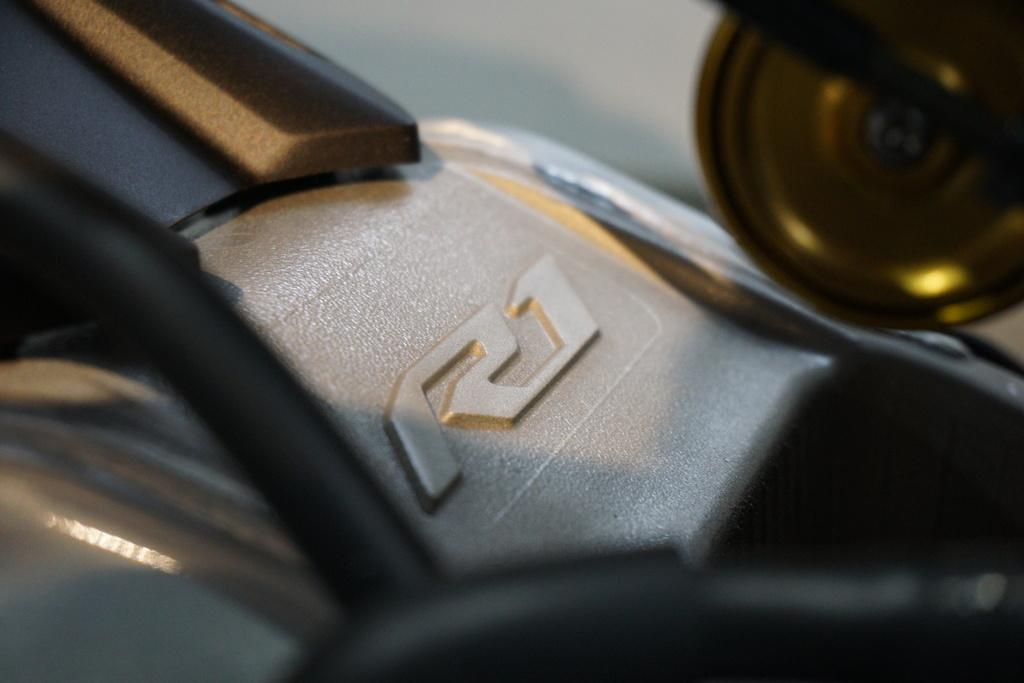What can be observed in the image? There is a zoomed-in image of an object. Can you describe the colors of the object in the image? The object has brown, black, and cream colors. What type of oven is visible in the image? There is no oven present in the image; it is a zoomed-in image of an object with brown, black, and cream colors. What addition problem can be solved using the numbers on the object in the image? There are no numbers visible on the object in the image, so it is not possible to solve an addition problem. 